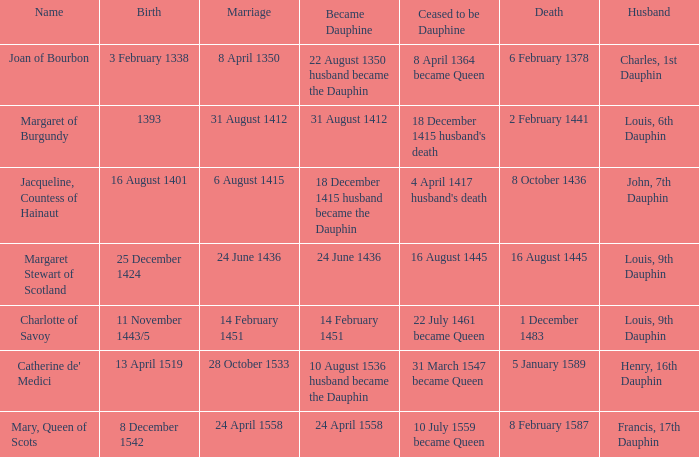When was became dauphine when birth is 1393? 31 August 1412. 